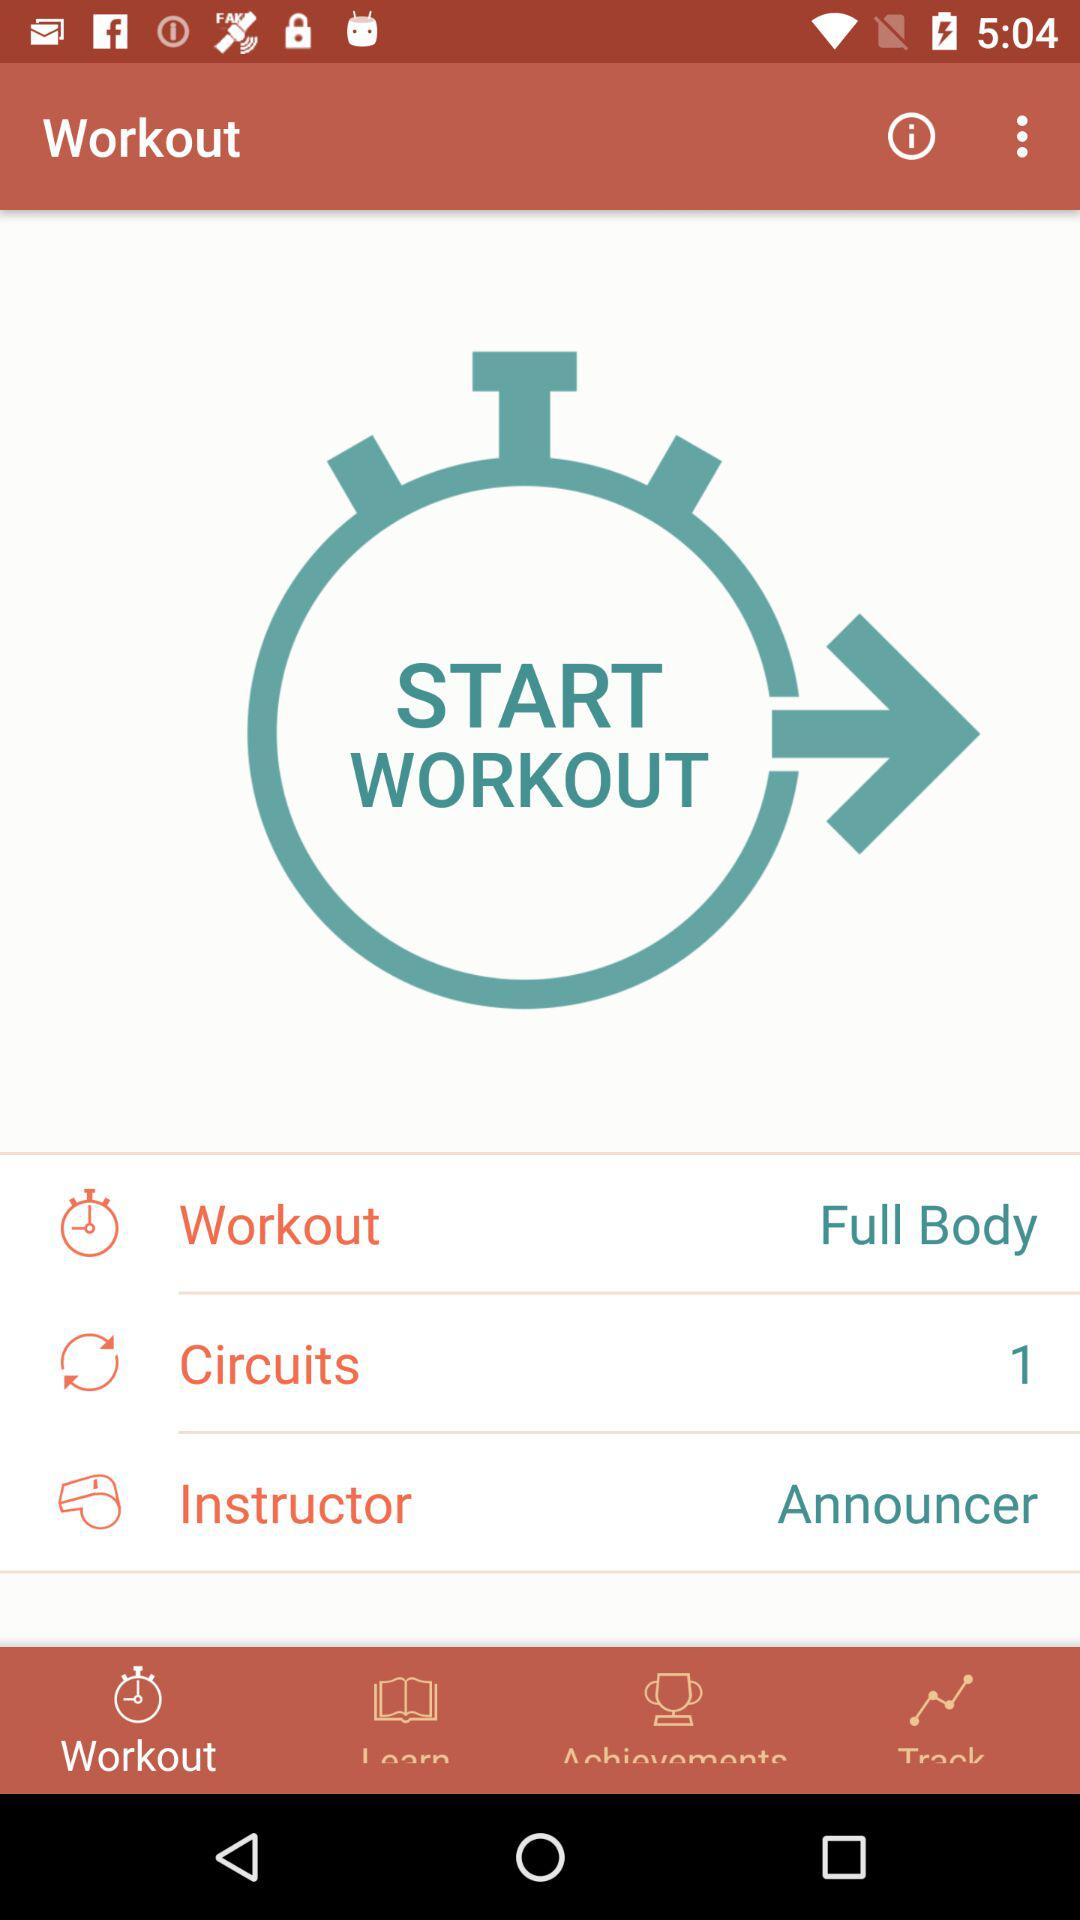How many circuits in total are there? There is 1 circuit. 